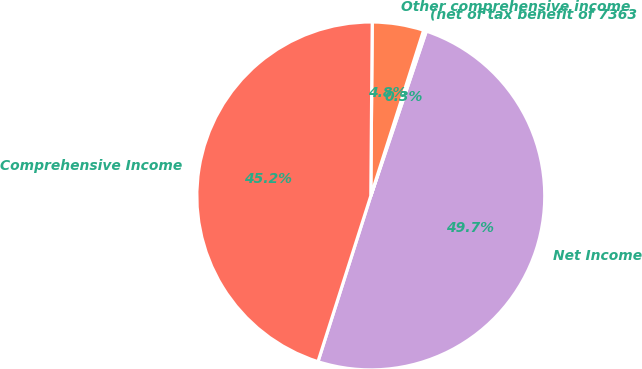Convert chart. <chart><loc_0><loc_0><loc_500><loc_500><pie_chart><fcel>Net Income<fcel>(net of tax benefit of 7363<fcel>Other comprehensive income<fcel>Comprehensive Income<nl><fcel>49.74%<fcel>0.26%<fcel>4.78%<fcel>45.22%<nl></chart> 